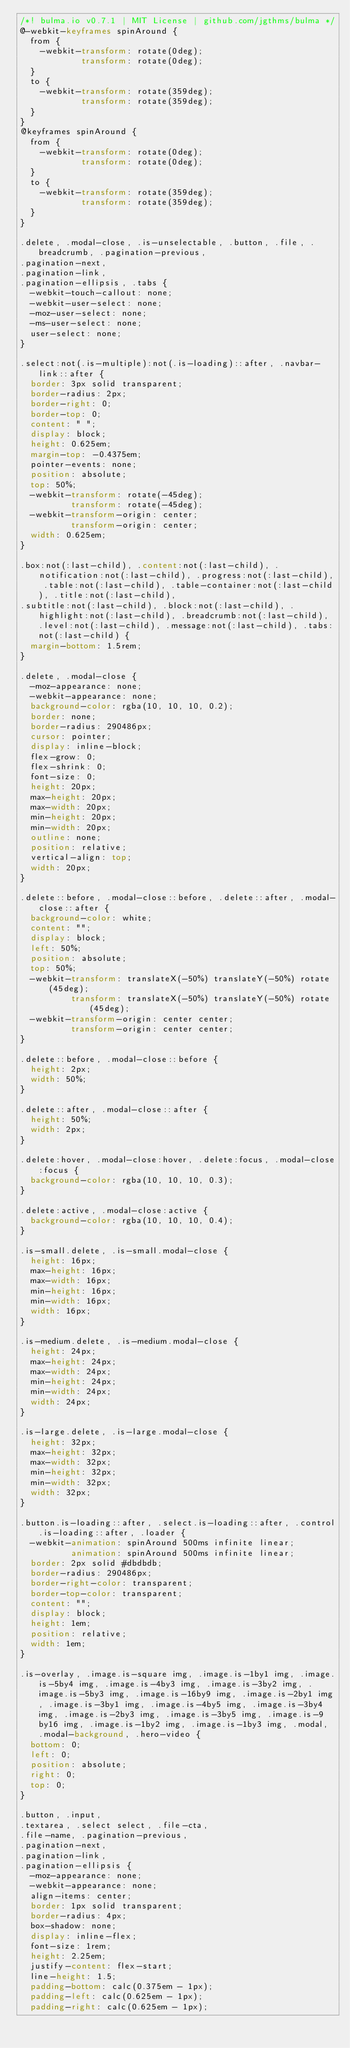Convert code to text. <code><loc_0><loc_0><loc_500><loc_500><_CSS_>/*! bulma.io v0.7.1 | MIT License | github.com/jgthms/bulma */
@-webkit-keyframes spinAround {
  from {
    -webkit-transform: rotate(0deg);
            transform: rotate(0deg);
  }
  to {
    -webkit-transform: rotate(359deg);
            transform: rotate(359deg);
  }
}
@keyframes spinAround {
  from {
    -webkit-transform: rotate(0deg);
            transform: rotate(0deg);
  }
  to {
    -webkit-transform: rotate(359deg);
            transform: rotate(359deg);
  }
}

.delete, .modal-close, .is-unselectable, .button, .file, .breadcrumb, .pagination-previous,
.pagination-next,
.pagination-link,
.pagination-ellipsis, .tabs {
  -webkit-touch-callout: none;
  -webkit-user-select: none;
  -moz-user-select: none;
  -ms-user-select: none;
  user-select: none;
}

.select:not(.is-multiple):not(.is-loading)::after, .navbar-link::after {
  border: 3px solid transparent;
  border-radius: 2px;
  border-right: 0;
  border-top: 0;
  content: " ";
  display: block;
  height: 0.625em;
  margin-top: -0.4375em;
  pointer-events: none;
  position: absolute;
  top: 50%;
  -webkit-transform: rotate(-45deg);
          transform: rotate(-45deg);
  -webkit-transform-origin: center;
          transform-origin: center;
  width: 0.625em;
}

.box:not(:last-child), .content:not(:last-child), .notification:not(:last-child), .progress:not(:last-child), .table:not(:last-child), .table-container:not(:last-child), .title:not(:last-child),
.subtitle:not(:last-child), .block:not(:last-child), .highlight:not(:last-child), .breadcrumb:not(:last-child), .level:not(:last-child), .message:not(:last-child), .tabs:not(:last-child) {
  margin-bottom: 1.5rem;
}

.delete, .modal-close {
  -moz-appearance: none;
  -webkit-appearance: none;
  background-color: rgba(10, 10, 10, 0.2);
  border: none;
  border-radius: 290486px;
  cursor: pointer;
  display: inline-block;
  flex-grow: 0;
  flex-shrink: 0;
  font-size: 0;
  height: 20px;
  max-height: 20px;
  max-width: 20px;
  min-height: 20px;
  min-width: 20px;
  outline: none;
  position: relative;
  vertical-align: top;
  width: 20px;
}

.delete::before, .modal-close::before, .delete::after, .modal-close::after {
  background-color: white;
  content: "";
  display: block;
  left: 50%;
  position: absolute;
  top: 50%;
  -webkit-transform: translateX(-50%) translateY(-50%) rotate(45deg);
          transform: translateX(-50%) translateY(-50%) rotate(45deg);
  -webkit-transform-origin: center center;
          transform-origin: center center;
}

.delete::before, .modal-close::before {
  height: 2px;
  width: 50%;
}

.delete::after, .modal-close::after {
  height: 50%;
  width: 2px;
}

.delete:hover, .modal-close:hover, .delete:focus, .modal-close:focus {
  background-color: rgba(10, 10, 10, 0.3);
}

.delete:active, .modal-close:active {
  background-color: rgba(10, 10, 10, 0.4);
}

.is-small.delete, .is-small.modal-close {
  height: 16px;
  max-height: 16px;
  max-width: 16px;
  min-height: 16px;
  min-width: 16px;
  width: 16px;
}

.is-medium.delete, .is-medium.modal-close {
  height: 24px;
  max-height: 24px;
  max-width: 24px;
  min-height: 24px;
  min-width: 24px;
  width: 24px;
}

.is-large.delete, .is-large.modal-close {
  height: 32px;
  max-height: 32px;
  max-width: 32px;
  min-height: 32px;
  min-width: 32px;
  width: 32px;
}

.button.is-loading::after, .select.is-loading::after, .control.is-loading::after, .loader {
  -webkit-animation: spinAround 500ms infinite linear;
          animation: spinAround 500ms infinite linear;
  border: 2px solid #dbdbdb;
  border-radius: 290486px;
  border-right-color: transparent;
  border-top-color: transparent;
  content: "";
  display: block;
  height: 1em;
  position: relative;
  width: 1em;
}

.is-overlay, .image.is-square img, .image.is-1by1 img, .image.is-5by4 img, .image.is-4by3 img, .image.is-3by2 img, .image.is-5by3 img, .image.is-16by9 img, .image.is-2by1 img, .image.is-3by1 img, .image.is-4by5 img, .image.is-3by4 img, .image.is-2by3 img, .image.is-3by5 img, .image.is-9by16 img, .image.is-1by2 img, .image.is-1by3 img, .modal, .modal-background, .hero-video {
  bottom: 0;
  left: 0;
  position: absolute;
  right: 0;
  top: 0;
}

.button, .input,
.textarea, .select select, .file-cta,
.file-name, .pagination-previous,
.pagination-next,
.pagination-link,
.pagination-ellipsis {
  -moz-appearance: none;
  -webkit-appearance: none;
  align-items: center;
  border: 1px solid transparent;
  border-radius: 4px;
  box-shadow: none;
  display: inline-flex;
  font-size: 1rem;
  height: 2.25em;
  justify-content: flex-start;
  line-height: 1.5;
  padding-bottom: calc(0.375em - 1px);
  padding-left: calc(0.625em - 1px);
  padding-right: calc(0.625em - 1px);</code> 